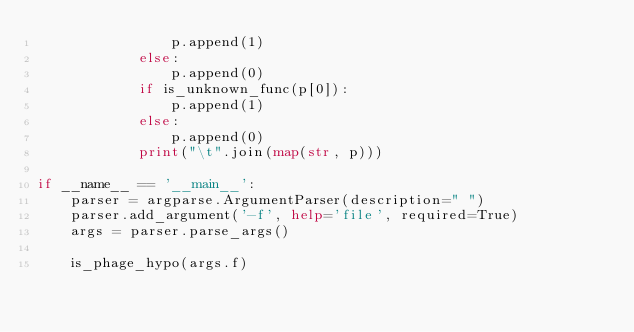<code> <loc_0><loc_0><loc_500><loc_500><_Python_>                p.append(1)
            else:
                p.append(0)
            if is_unknown_func(p[0]):
                p.append(1)
            else:
                p.append(0)
            print("\t".join(map(str, p)))

if __name__ == '__main__':
    parser = argparse.ArgumentParser(description=" ")
    parser.add_argument('-f', help='file', required=True)
    args = parser.parse_args()

    is_phage_hypo(args.f)
</code> 